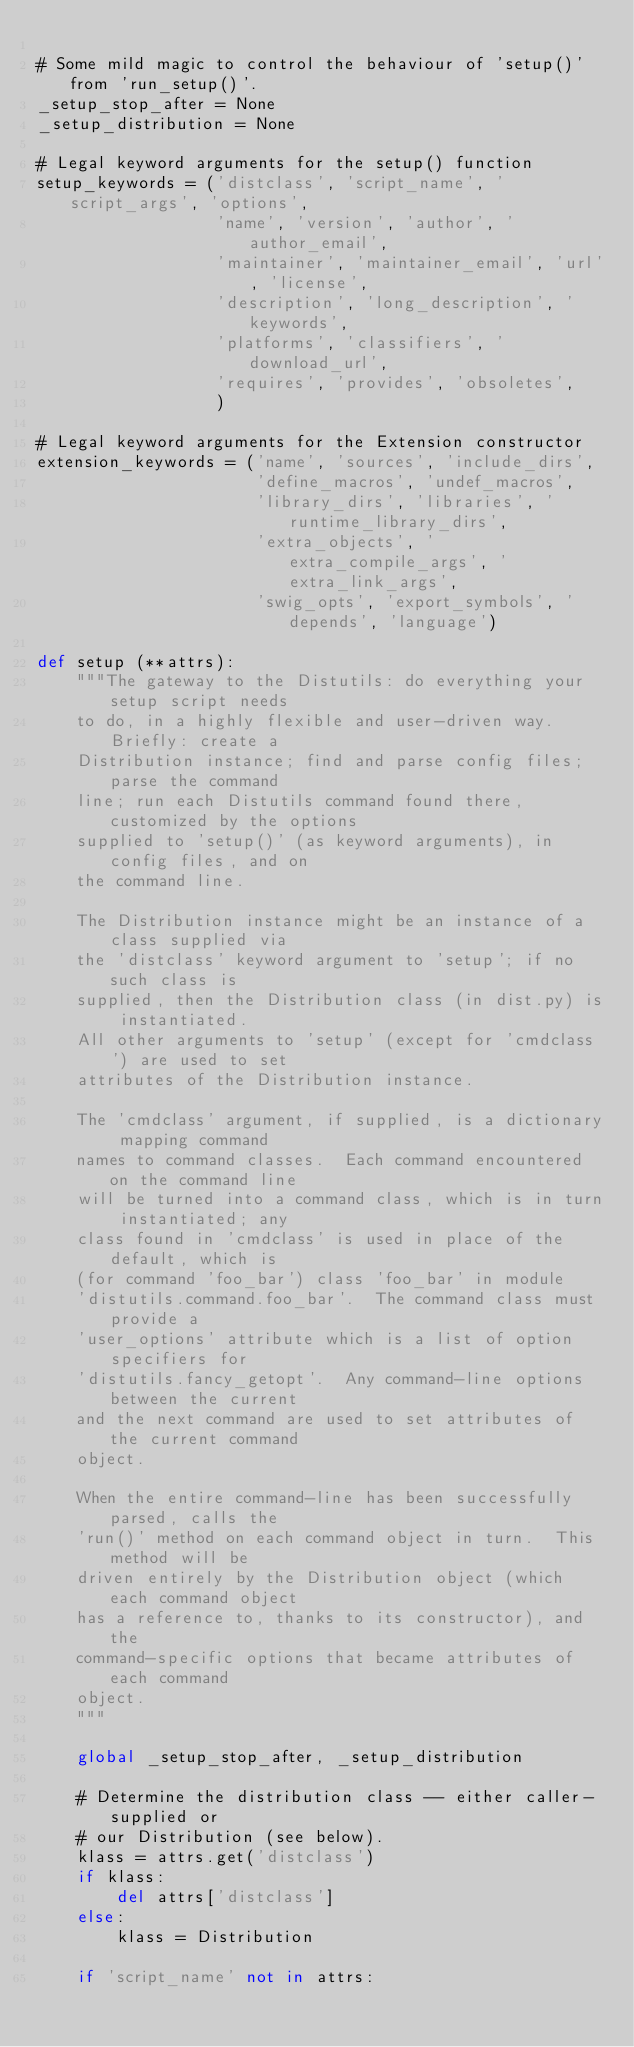Convert code to text. <code><loc_0><loc_0><loc_500><loc_500><_Python_>
# Some mild magic to control the behaviour of 'setup()' from 'run_setup()'.
_setup_stop_after = None
_setup_distribution = None

# Legal keyword arguments for the setup() function
setup_keywords = ('distclass', 'script_name', 'script_args', 'options',
                  'name', 'version', 'author', 'author_email',
                  'maintainer', 'maintainer_email', 'url', 'license',
                  'description', 'long_description', 'keywords',
                  'platforms', 'classifiers', 'download_url',
                  'requires', 'provides', 'obsoletes',
                  )

# Legal keyword arguments for the Extension constructor
extension_keywords = ('name', 'sources', 'include_dirs',
                      'define_macros', 'undef_macros',
                      'library_dirs', 'libraries', 'runtime_library_dirs',
                      'extra_objects', 'extra_compile_args', 'extra_link_args',
                      'swig_opts', 'export_symbols', 'depends', 'language')

def setup (**attrs):
    """The gateway to the Distutils: do everything your setup script needs
    to do, in a highly flexible and user-driven way.  Briefly: create a
    Distribution instance; find and parse config files; parse the command
    line; run each Distutils command found there, customized by the options
    supplied to 'setup()' (as keyword arguments), in config files, and on
    the command line.

    The Distribution instance might be an instance of a class supplied via
    the 'distclass' keyword argument to 'setup'; if no such class is
    supplied, then the Distribution class (in dist.py) is instantiated.
    All other arguments to 'setup' (except for 'cmdclass') are used to set
    attributes of the Distribution instance.

    The 'cmdclass' argument, if supplied, is a dictionary mapping command
    names to command classes.  Each command encountered on the command line
    will be turned into a command class, which is in turn instantiated; any
    class found in 'cmdclass' is used in place of the default, which is
    (for command 'foo_bar') class 'foo_bar' in module
    'distutils.command.foo_bar'.  The command class must provide a
    'user_options' attribute which is a list of option specifiers for
    'distutils.fancy_getopt'.  Any command-line options between the current
    and the next command are used to set attributes of the current command
    object.

    When the entire command-line has been successfully parsed, calls the
    'run()' method on each command object in turn.  This method will be
    driven entirely by the Distribution object (which each command object
    has a reference to, thanks to its constructor), and the
    command-specific options that became attributes of each command
    object.
    """

    global _setup_stop_after, _setup_distribution

    # Determine the distribution class -- either caller-supplied or
    # our Distribution (see below).
    klass = attrs.get('distclass')
    if klass:
        del attrs['distclass']
    else:
        klass = Distribution

    if 'script_name' not in attrs:</code> 